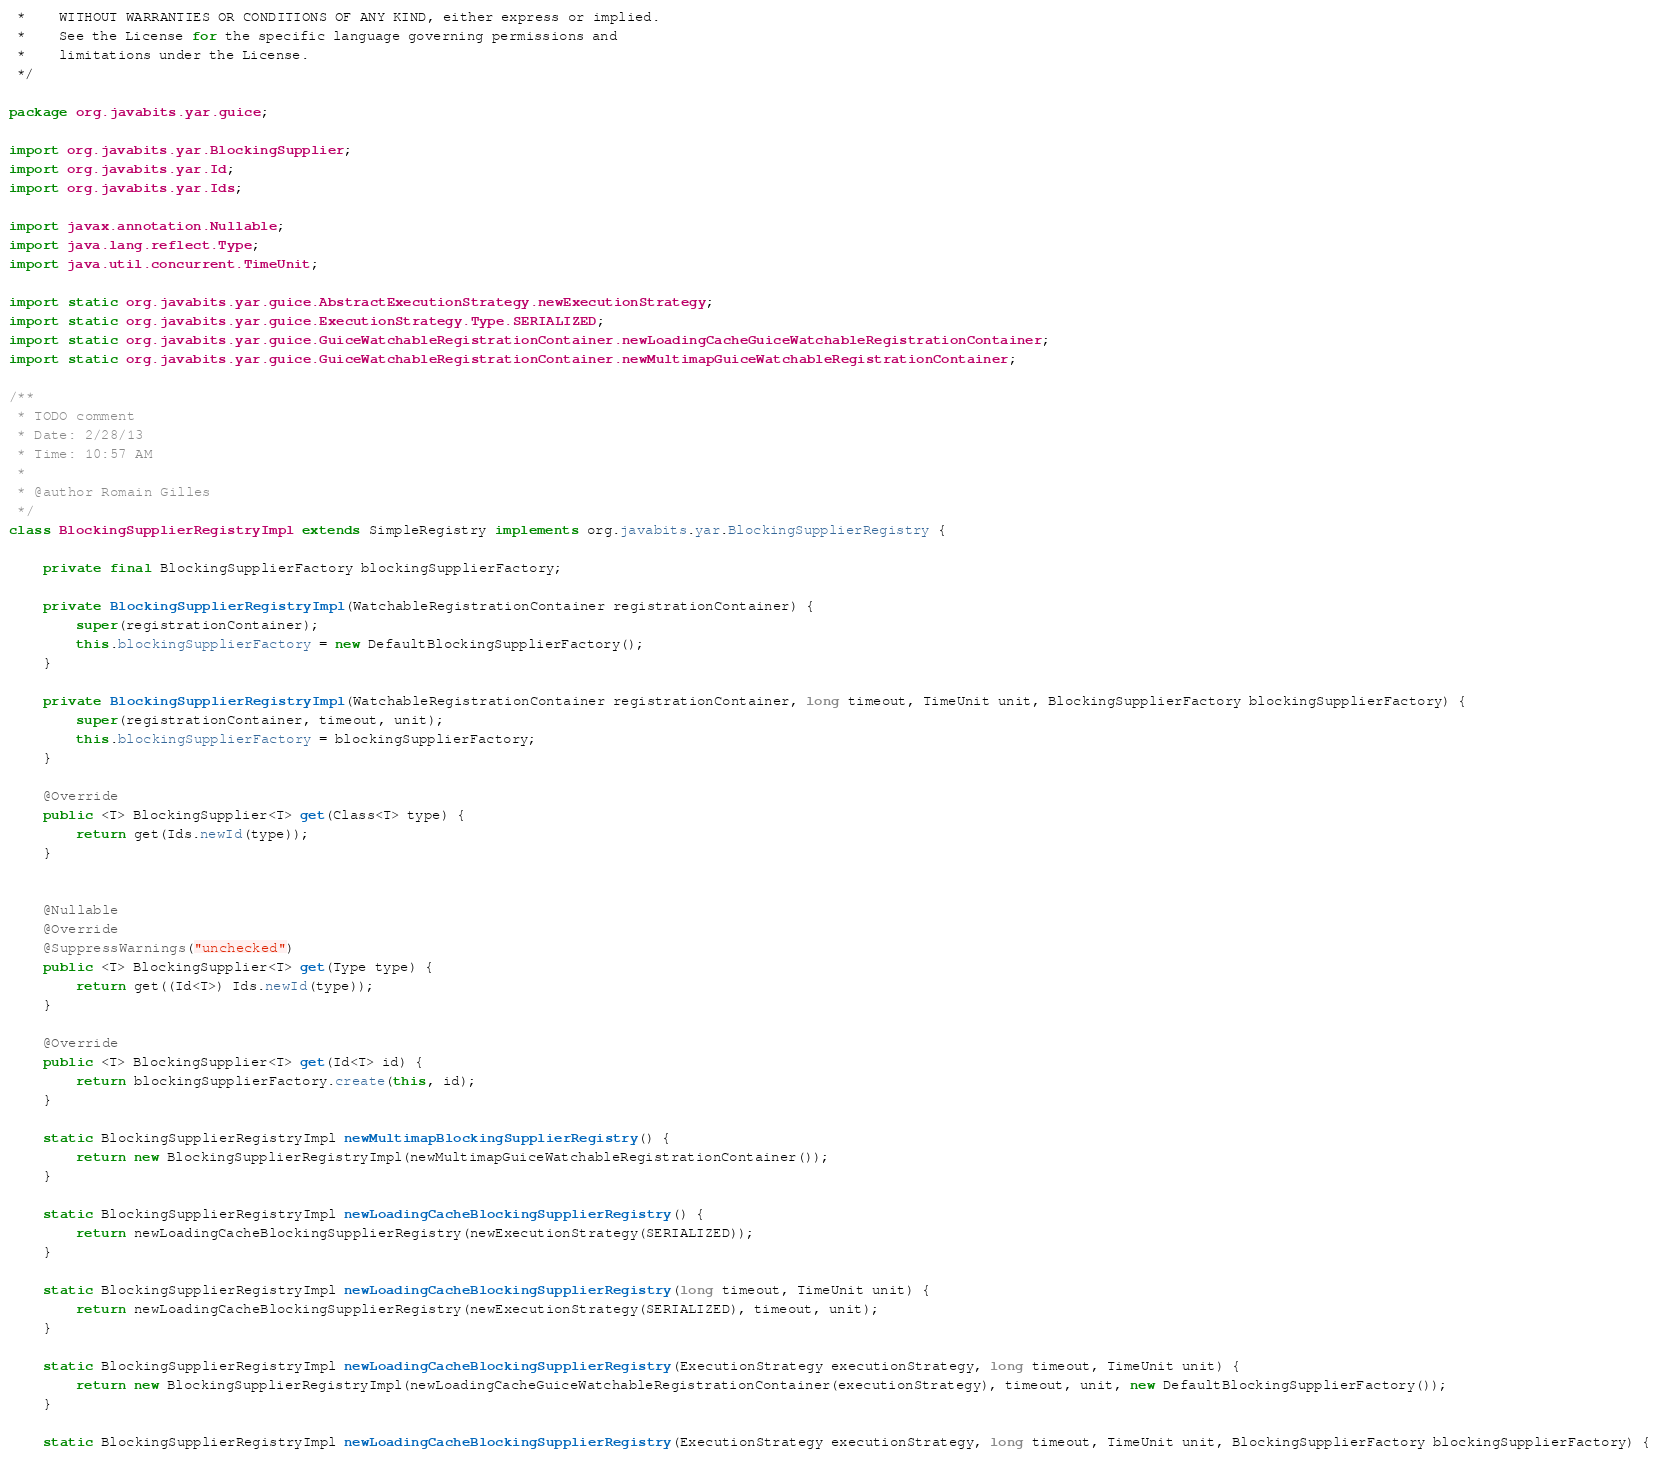Convert code to text. <code><loc_0><loc_0><loc_500><loc_500><_Java_> *    WITHOUT WARRANTIES OR CONDITIONS OF ANY KIND, either express or implied.
 *    See the License for the specific language governing permissions and
 *    limitations under the License.
 */

package org.javabits.yar.guice;

import org.javabits.yar.BlockingSupplier;
import org.javabits.yar.Id;
import org.javabits.yar.Ids;

import javax.annotation.Nullable;
import java.lang.reflect.Type;
import java.util.concurrent.TimeUnit;

import static org.javabits.yar.guice.AbstractExecutionStrategy.newExecutionStrategy;
import static org.javabits.yar.guice.ExecutionStrategy.Type.SERIALIZED;
import static org.javabits.yar.guice.GuiceWatchableRegistrationContainer.newLoadingCacheGuiceWatchableRegistrationContainer;
import static org.javabits.yar.guice.GuiceWatchableRegistrationContainer.newMultimapGuiceWatchableRegistrationContainer;

/**
 * TODO comment
 * Date: 2/28/13
 * Time: 10:57 AM
 *
 * @author Romain Gilles
 */
class BlockingSupplierRegistryImpl extends SimpleRegistry implements org.javabits.yar.BlockingSupplierRegistry {

    private final BlockingSupplierFactory blockingSupplierFactory;

    private BlockingSupplierRegistryImpl(WatchableRegistrationContainer registrationContainer) {
        super(registrationContainer);
        this.blockingSupplierFactory = new DefaultBlockingSupplierFactory();
    }

    private BlockingSupplierRegistryImpl(WatchableRegistrationContainer registrationContainer, long timeout, TimeUnit unit, BlockingSupplierFactory blockingSupplierFactory) {
        super(registrationContainer, timeout, unit);
        this.blockingSupplierFactory = blockingSupplierFactory;
    }

    @Override
    public <T> BlockingSupplier<T> get(Class<T> type) {
        return get(Ids.newId(type));
    }


    @Nullable
    @Override
    @SuppressWarnings("unchecked")
    public <T> BlockingSupplier<T> get(Type type) {
        return get((Id<T>) Ids.newId(type));
    }

    @Override
    public <T> BlockingSupplier<T> get(Id<T> id) {
        return blockingSupplierFactory.create(this, id);
    }

    static BlockingSupplierRegistryImpl newMultimapBlockingSupplierRegistry() {
        return new BlockingSupplierRegistryImpl(newMultimapGuiceWatchableRegistrationContainer());
    }

    static BlockingSupplierRegistryImpl newLoadingCacheBlockingSupplierRegistry() {
        return newLoadingCacheBlockingSupplierRegistry(newExecutionStrategy(SERIALIZED));
    }

    static BlockingSupplierRegistryImpl newLoadingCacheBlockingSupplierRegistry(long timeout, TimeUnit unit) {
        return newLoadingCacheBlockingSupplierRegistry(newExecutionStrategy(SERIALIZED), timeout, unit);
    }

    static BlockingSupplierRegistryImpl newLoadingCacheBlockingSupplierRegistry(ExecutionStrategy executionStrategy, long timeout, TimeUnit unit) {
        return new BlockingSupplierRegistryImpl(newLoadingCacheGuiceWatchableRegistrationContainer(executionStrategy), timeout, unit, new DefaultBlockingSupplierFactory());
    }

    static BlockingSupplierRegistryImpl newLoadingCacheBlockingSupplierRegistry(ExecutionStrategy executionStrategy, long timeout, TimeUnit unit, BlockingSupplierFactory blockingSupplierFactory) {</code> 